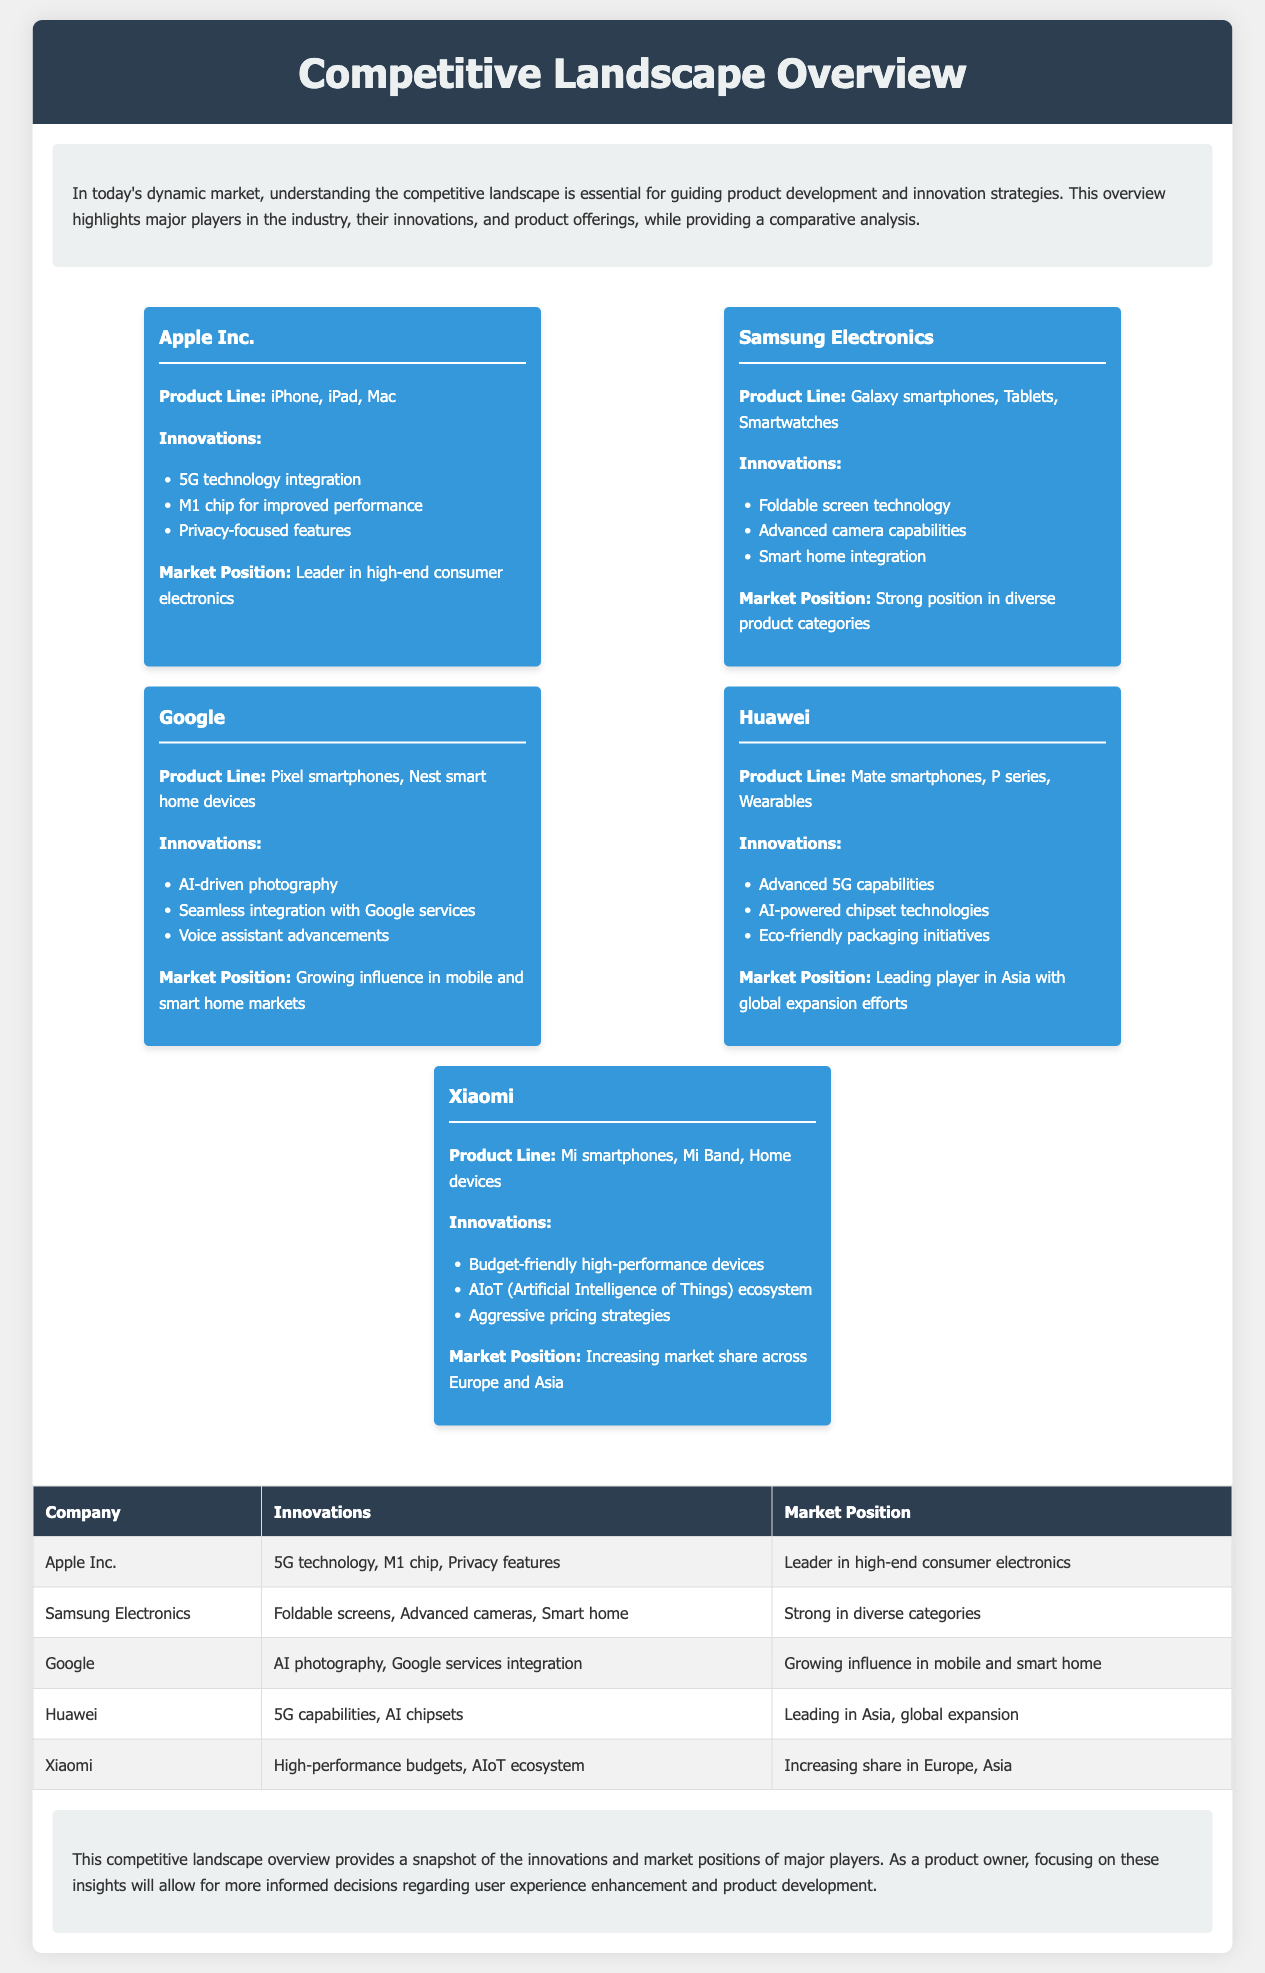What are the product lines of Apple Inc.? The product lines of Apple Inc. are mentioned in the document as iPhone, iPad, and Mac.
Answer: iPhone, iPad, Mac Which company offers advanced camera capabilities? The innovations section lists advanced camera capabilities under Samsung Electronics.
Answer: Samsung Electronics What innovative technology is associated with Huawei? Huawei is noted for advanced 5G capabilities mentioned in the innovations section.
Answer: Advanced 5G capabilities What is the market position of Xiaomi? The document specifies Xiaomi's market position as increasing market share across Europe and Asia.
Answer: Increasing market share across Europe and Asia How many major players are highlighted in the document? The document presents five major players in the industry as detailed in the overview.
Answer: Five Which company is recognized for privacy-focused features? Privacy-focused features are specifically listed under Apple Inc. in the innovations section.
Answer: Apple Inc What technology integration is a focus for Google? The document highlights Google's seamless integration with Google services as a key innovation.
Answer: Seamless integration with Google services Which player is described as a leader in high-end consumer electronics? The market position section states that Apple Inc. is the leader in high-end consumer electronics.
Answer: Apple Inc 